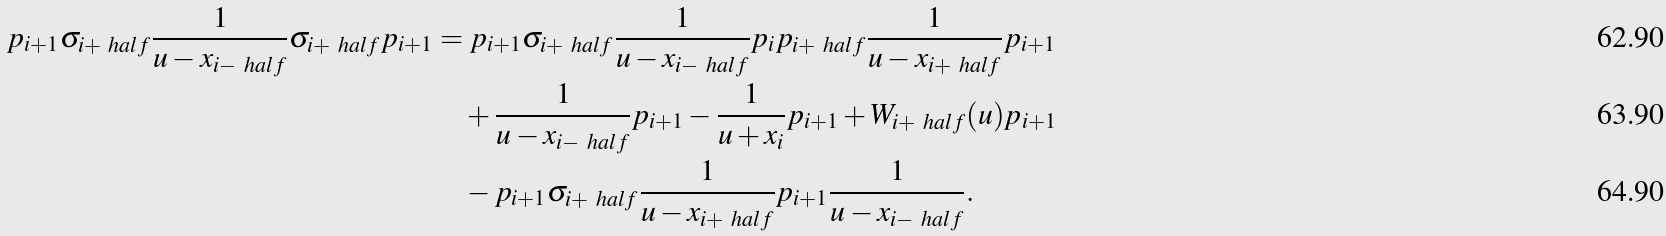Convert formula to latex. <formula><loc_0><loc_0><loc_500><loc_500>p _ { i + 1 } \sigma _ { i + \ h a l f } \frac { 1 } { u - x _ { i - \ h a l f } } \sigma _ { i + \ h a l f } p _ { i + 1 } & = p _ { i + 1 } \sigma _ { i + \ h a l f } \frac { 1 } { u - x _ { i - \ h a l f } } p _ { i } p _ { i + \ h a l f } \frac { 1 } { u - x _ { i + \ h a l f } } p _ { i + 1 } \\ & \quad + \frac { 1 } { u - x _ { i - \ h a l f } } p _ { i + 1 } - \frac { 1 } { u + x _ { i } } p _ { i + 1 } + W _ { i + \ h a l f } ( u ) p _ { i + 1 } \\ & \quad - p _ { i + 1 } \sigma _ { i + \ h a l f } \frac { 1 } { u - x _ { i + \ h a l f } } p _ { i + 1 } \frac { 1 } { u - x _ { i - \ h a l f } } .</formula> 